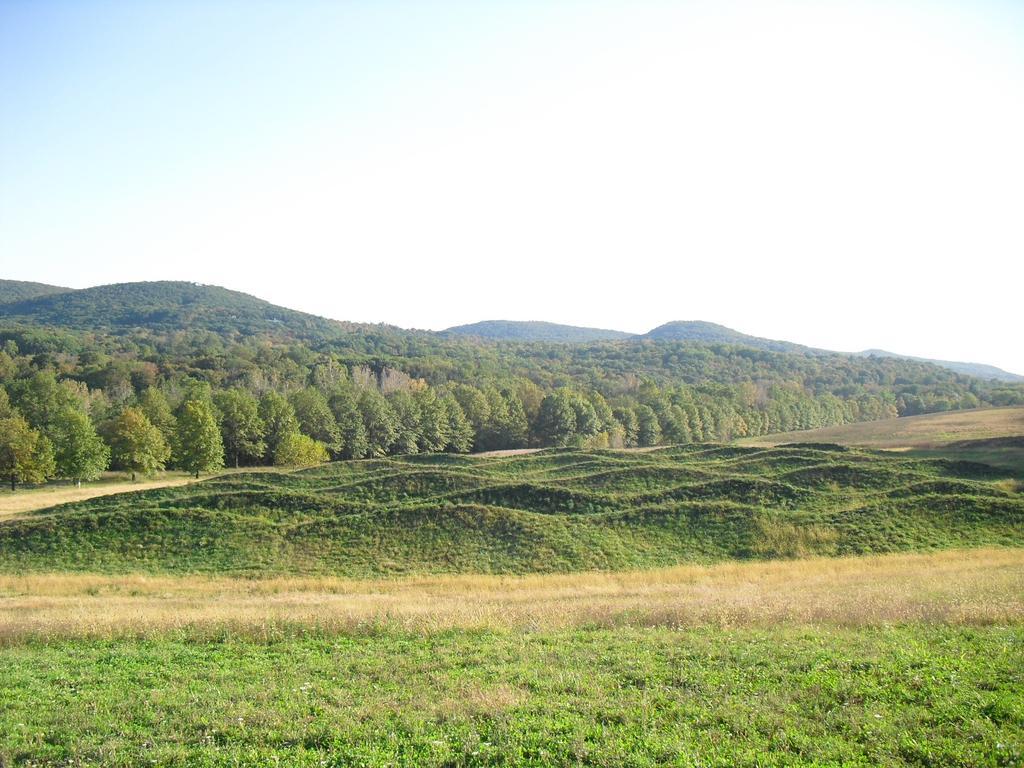How would you summarize this image in a sentence or two? In this image we can see sky with clouds, hills, trees, grass and ground. 